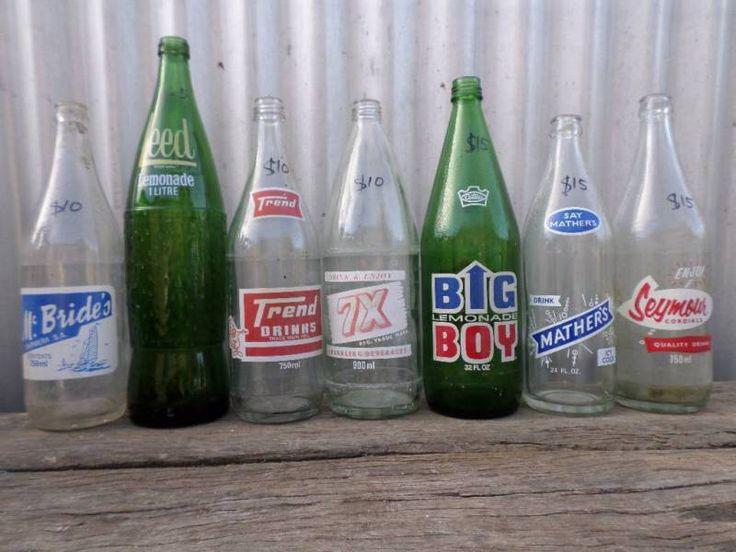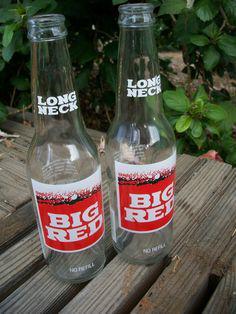The first image is the image on the left, the second image is the image on the right. Given the left and right images, does the statement "The right image contains exactly two bottles." hold true? Answer yes or no. Yes. The first image is the image on the left, the second image is the image on the right. Analyze the images presented: Is the assertion "The right image includes multiple bottles with the same red-and-white labels, while the left image contains no identical bottles." valid? Answer yes or no. Yes. 